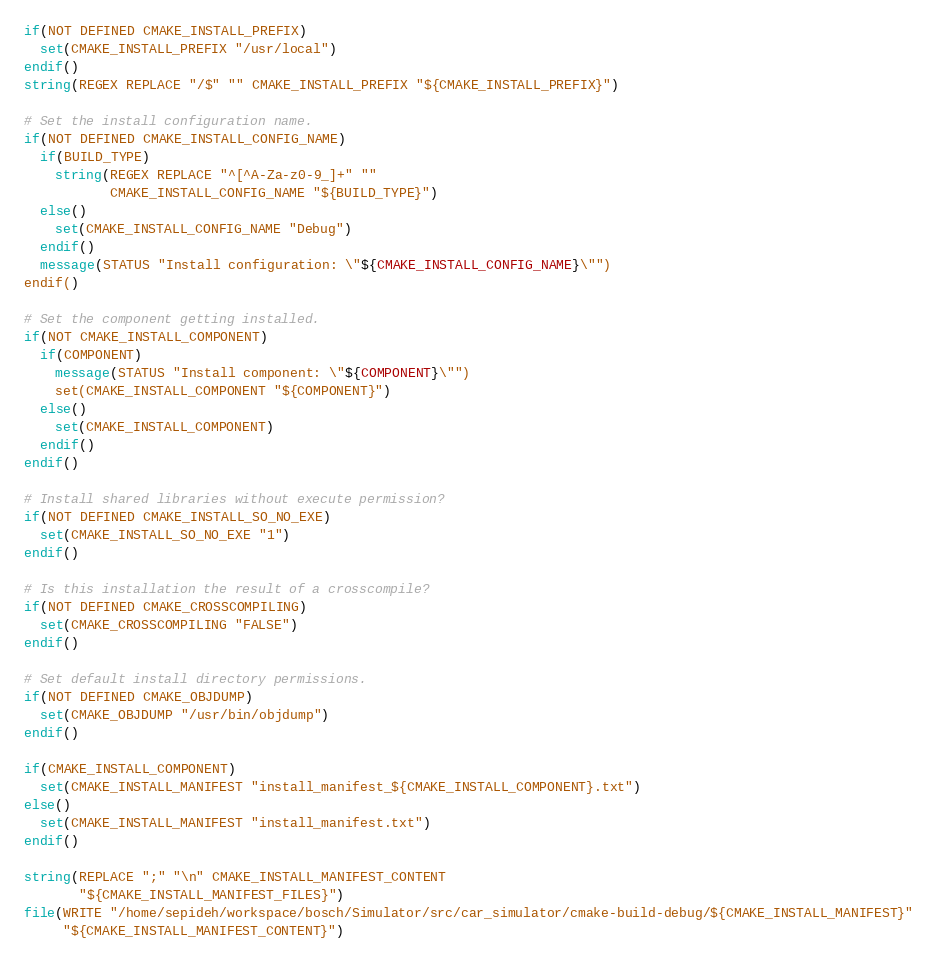Convert code to text. <code><loc_0><loc_0><loc_500><loc_500><_CMake_>if(NOT DEFINED CMAKE_INSTALL_PREFIX)
  set(CMAKE_INSTALL_PREFIX "/usr/local")
endif()
string(REGEX REPLACE "/$" "" CMAKE_INSTALL_PREFIX "${CMAKE_INSTALL_PREFIX}")

# Set the install configuration name.
if(NOT DEFINED CMAKE_INSTALL_CONFIG_NAME)
  if(BUILD_TYPE)
    string(REGEX REPLACE "^[^A-Za-z0-9_]+" ""
           CMAKE_INSTALL_CONFIG_NAME "${BUILD_TYPE}")
  else()
    set(CMAKE_INSTALL_CONFIG_NAME "Debug")
  endif()
  message(STATUS "Install configuration: \"${CMAKE_INSTALL_CONFIG_NAME}\"")
endif()

# Set the component getting installed.
if(NOT CMAKE_INSTALL_COMPONENT)
  if(COMPONENT)
    message(STATUS "Install component: \"${COMPONENT}\"")
    set(CMAKE_INSTALL_COMPONENT "${COMPONENT}")
  else()
    set(CMAKE_INSTALL_COMPONENT)
  endif()
endif()

# Install shared libraries without execute permission?
if(NOT DEFINED CMAKE_INSTALL_SO_NO_EXE)
  set(CMAKE_INSTALL_SO_NO_EXE "1")
endif()

# Is this installation the result of a crosscompile?
if(NOT DEFINED CMAKE_CROSSCOMPILING)
  set(CMAKE_CROSSCOMPILING "FALSE")
endif()

# Set default install directory permissions.
if(NOT DEFINED CMAKE_OBJDUMP)
  set(CMAKE_OBJDUMP "/usr/bin/objdump")
endif()

if(CMAKE_INSTALL_COMPONENT)
  set(CMAKE_INSTALL_MANIFEST "install_manifest_${CMAKE_INSTALL_COMPONENT}.txt")
else()
  set(CMAKE_INSTALL_MANIFEST "install_manifest.txt")
endif()

string(REPLACE ";" "\n" CMAKE_INSTALL_MANIFEST_CONTENT
       "${CMAKE_INSTALL_MANIFEST_FILES}")
file(WRITE "/home/sepideh/workspace/bosch/Simulator/src/car_simulator/cmake-build-debug/${CMAKE_INSTALL_MANIFEST}"
     "${CMAKE_INSTALL_MANIFEST_CONTENT}")
</code> 